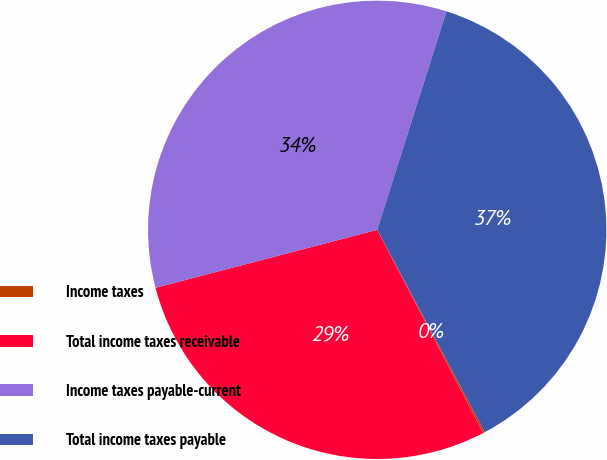Convert chart. <chart><loc_0><loc_0><loc_500><loc_500><pie_chart><fcel>Income taxes<fcel>Total income taxes receivable<fcel>Income taxes payable-current<fcel>Total income taxes payable<nl><fcel>0.13%<fcel>28.58%<fcel>33.95%<fcel>37.34%<nl></chart> 